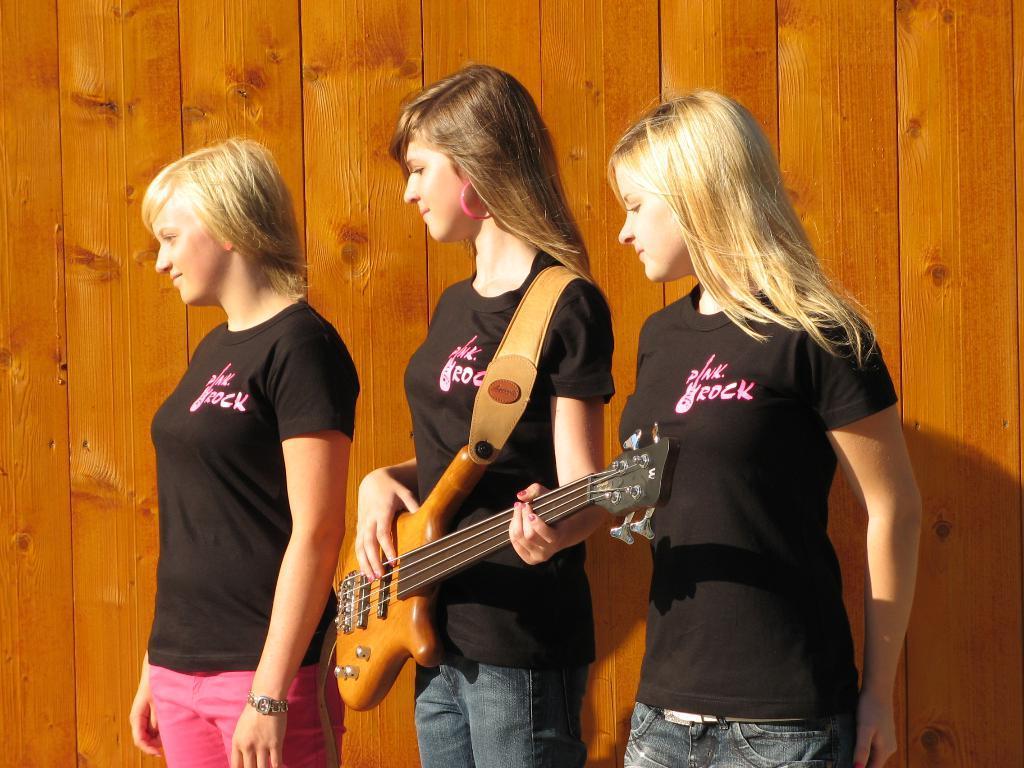Please provide a concise description of this image. As we can see in the image there are three women standing and wearing black color t shirts. The woman who is standing in the middle is holding guitar. 